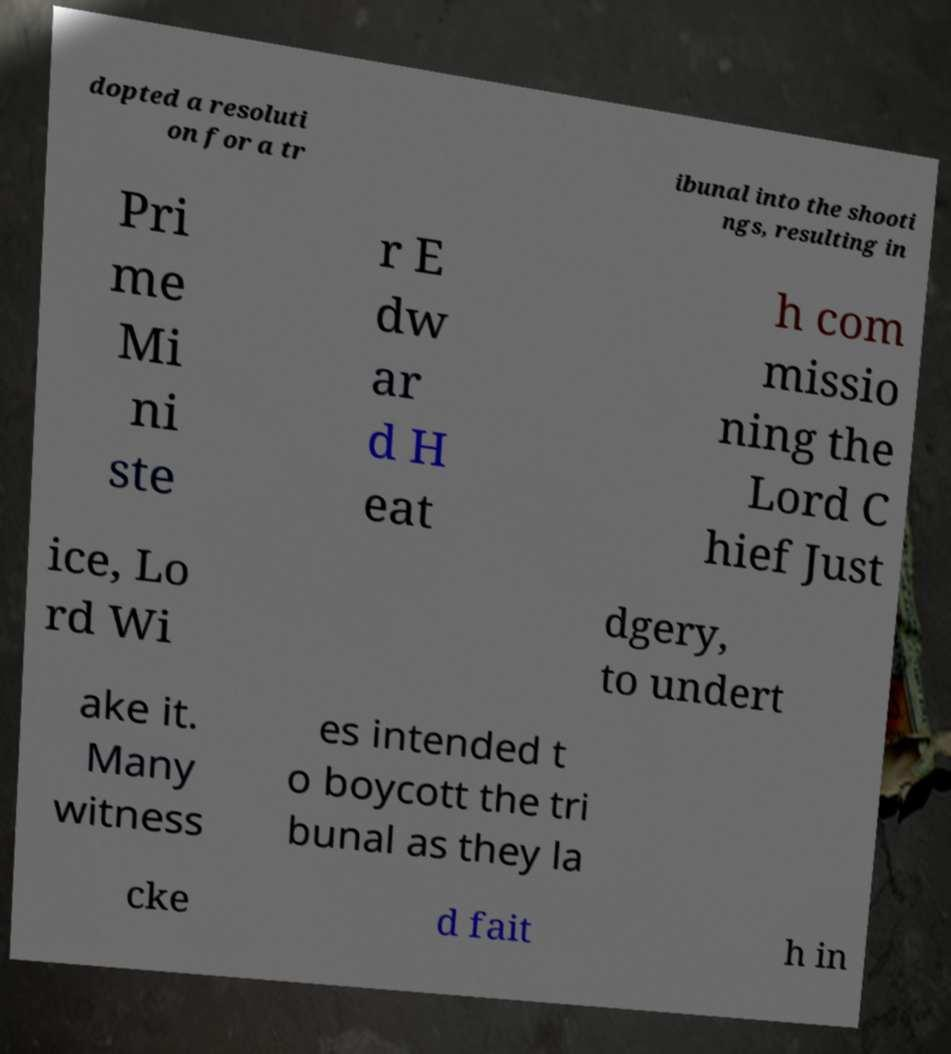Please read and relay the text visible in this image. What does it say? dopted a resoluti on for a tr ibunal into the shooti ngs, resulting in Pri me Mi ni ste r E dw ar d H eat h com missio ning the Lord C hief Just ice, Lo rd Wi dgery, to undert ake it. Many witness es intended t o boycott the tri bunal as they la cke d fait h in 